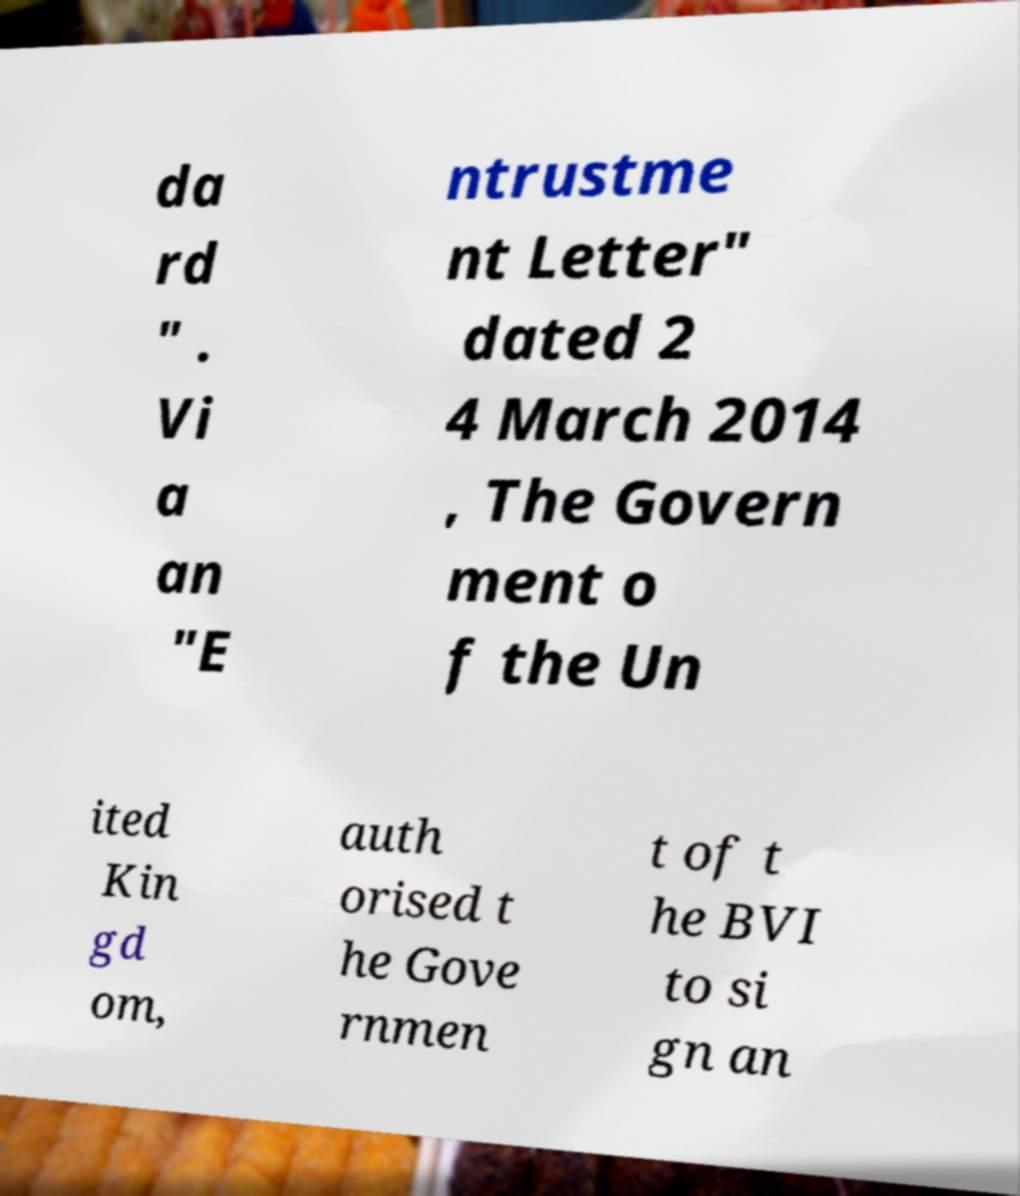For documentation purposes, I need the text within this image transcribed. Could you provide that? da rd " . Vi a an "E ntrustme nt Letter" dated 2 4 March 2014 , The Govern ment o f the Un ited Kin gd om, auth orised t he Gove rnmen t of t he BVI to si gn an 